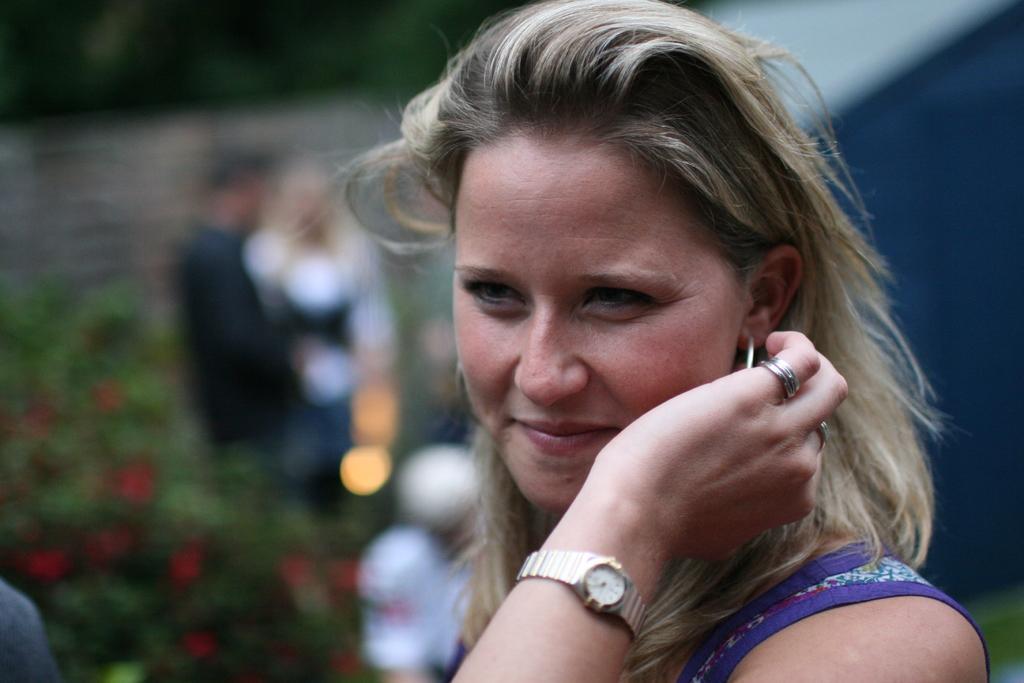Can you describe this image briefly? In this image there is a woman with a smile on her face, behind the woman there is a couple standing. 